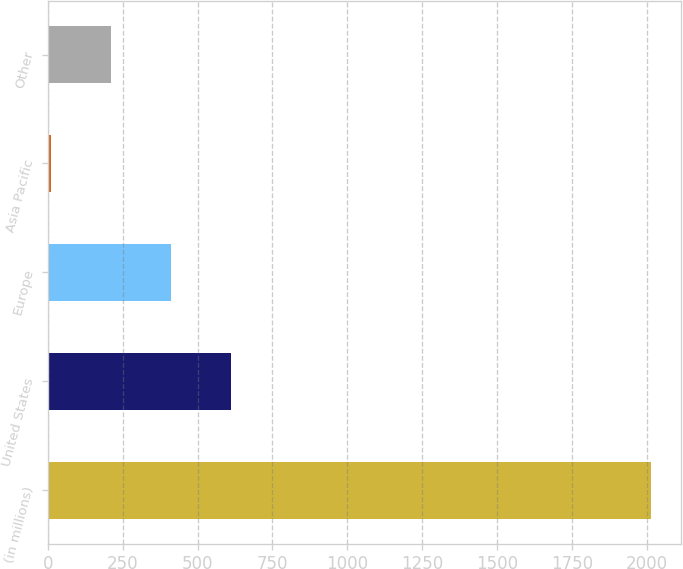<chart> <loc_0><loc_0><loc_500><loc_500><bar_chart><fcel>(in millions)<fcel>United States<fcel>Europe<fcel>Asia Pacific<fcel>Other<nl><fcel>2014<fcel>612.6<fcel>412.4<fcel>12<fcel>212.2<nl></chart> 